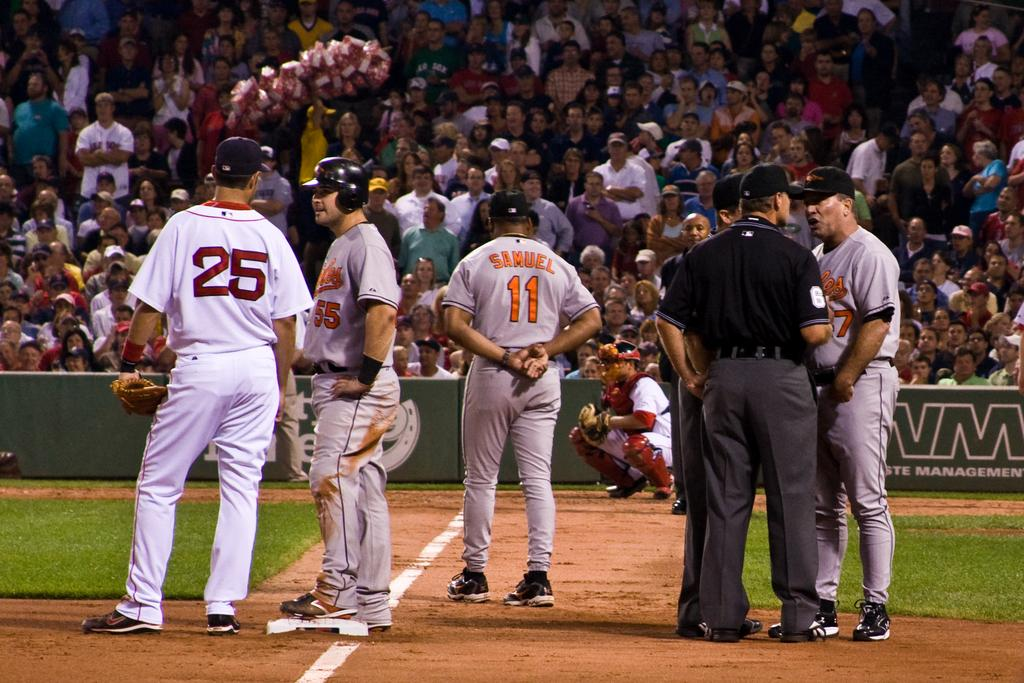Provide a one-sentence caption for the provided image. A baseball player with the name Samuel printed on the back of his jersey stands with other players. 